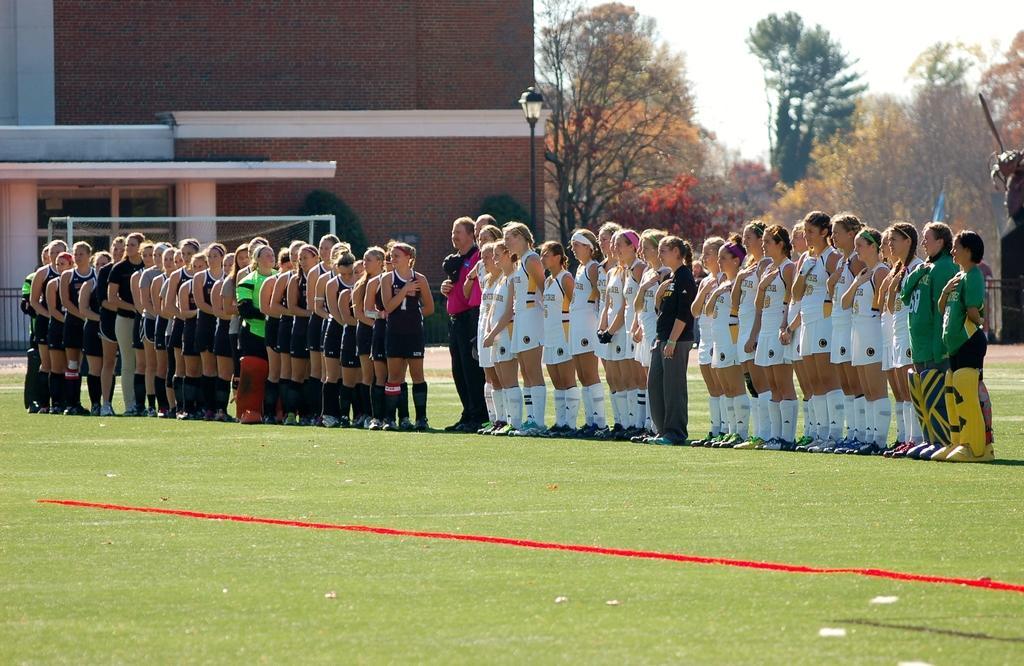Can you describe this image briefly? In this picture I can see group of people standing on the grass, there is a football net, light, pole, a building, trees, and in the background there is sky. 